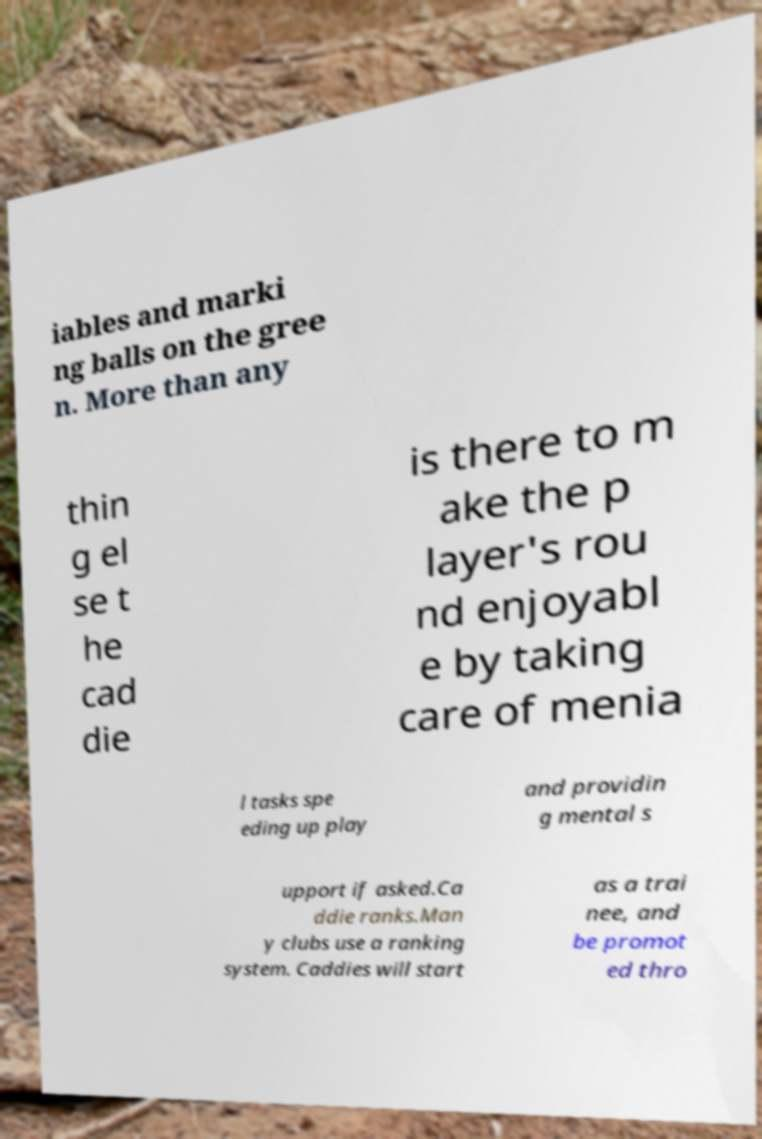Could you assist in decoding the text presented in this image and type it out clearly? iables and marki ng balls on the gree n. More than any thin g el se t he cad die is there to m ake the p layer's rou nd enjoyabl e by taking care of menia l tasks spe eding up play and providin g mental s upport if asked.Ca ddie ranks.Man y clubs use a ranking system. Caddies will start as a trai nee, and be promot ed thro 